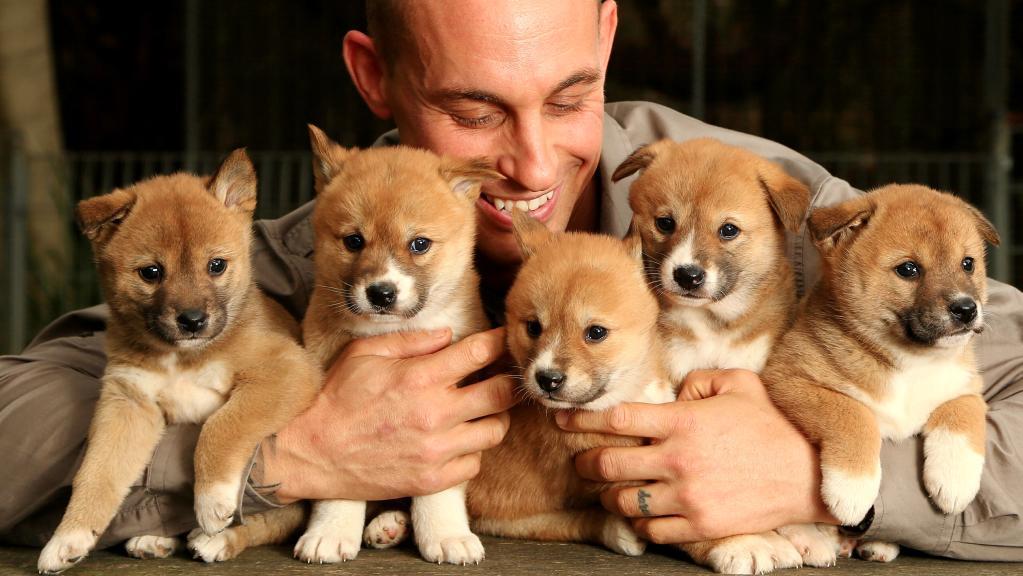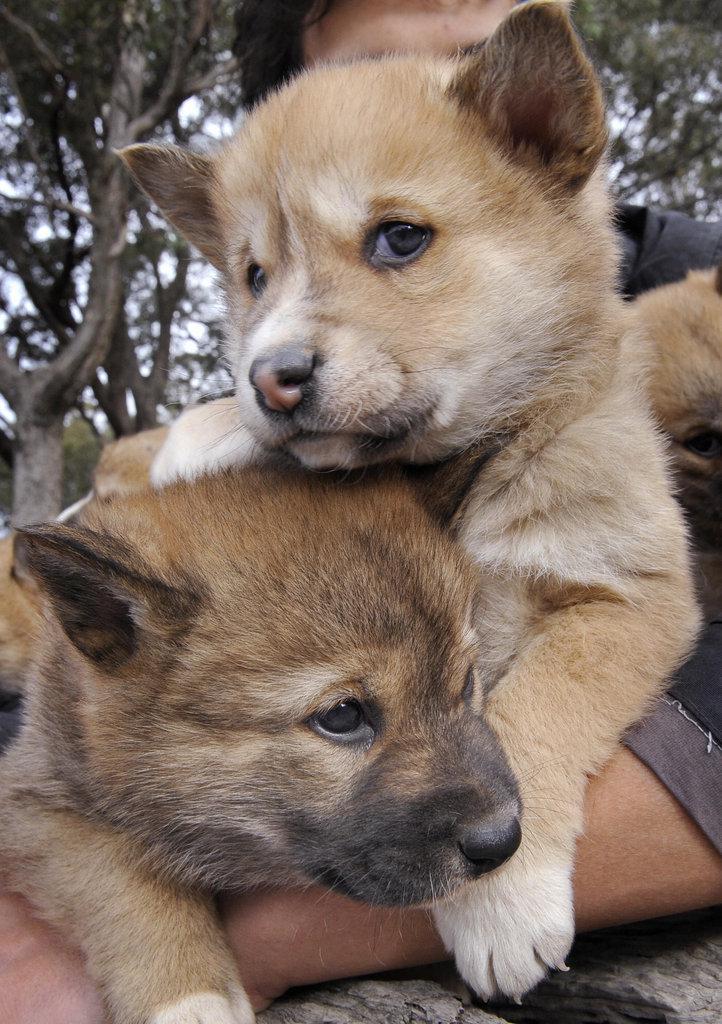The first image is the image on the left, the second image is the image on the right. Evaluate the accuracy of this statement regarding the images: "In the image on the right there are 2 puppies.". Is it true? Answer yes or no. Yes. The first image is the image on the left, the second image is the image on the right. Assess this claim about the two images: "At least one person is behind exactly two young dogs in the right image.". Correct or not? Answer yes or no. Yes. 